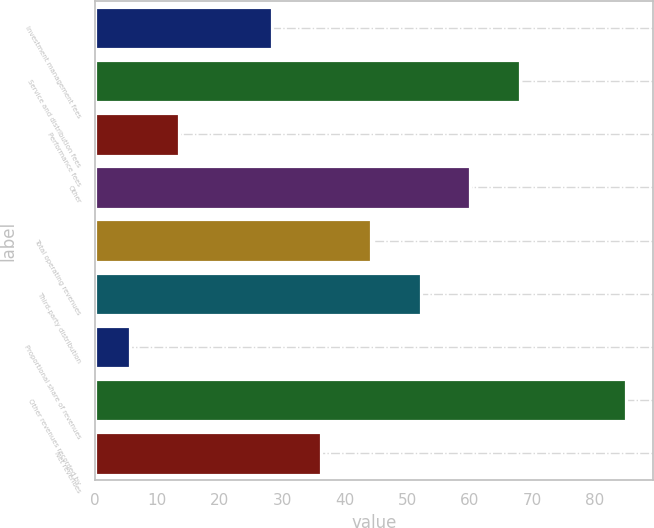Convert chart to OTSL. <chart><loc_0><loc_0><loc_500><loc_500><bar_chart><fcel>Investment management fees<fcel>Service and distribution fees<fcel>Performance fees<fcel>Other<fcel>Total operating revenues<fcel>Third-party distribution<fcel>Proportional share of revenues<fcel>Other revenues recorded by<fcel>Net revenues<nl><fcel>28.3<fcel>68<fcel>13.54<fcel>60.06<fcel>44.18<fcel>52.12<fcel>5.6<fcel>85<fcel>36.24<nl></chart> 